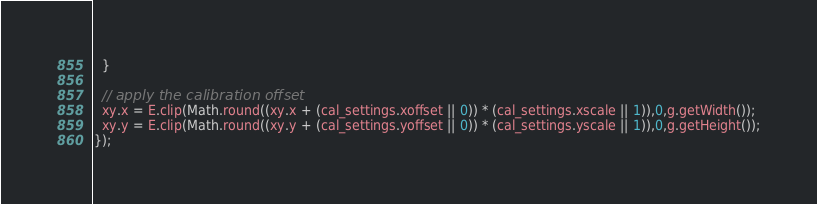Convert code to text. <code><loc_0><loc_0><loc_500><loc_500><_JavaScript_>  }

  // apply the calibration offset
  xy.x = E.clip(Math.round((xy.x + (cal_settings.xoffset || 0)) * (cal_settings.xscale || 1)),0,g.getWidth());
  xy.y = E.clip(Math.round((xy.y + (cal_settings.yoffset || 0)) * (cal_settings.yscale || 1)),0,g.getHeight());
});
</code> 